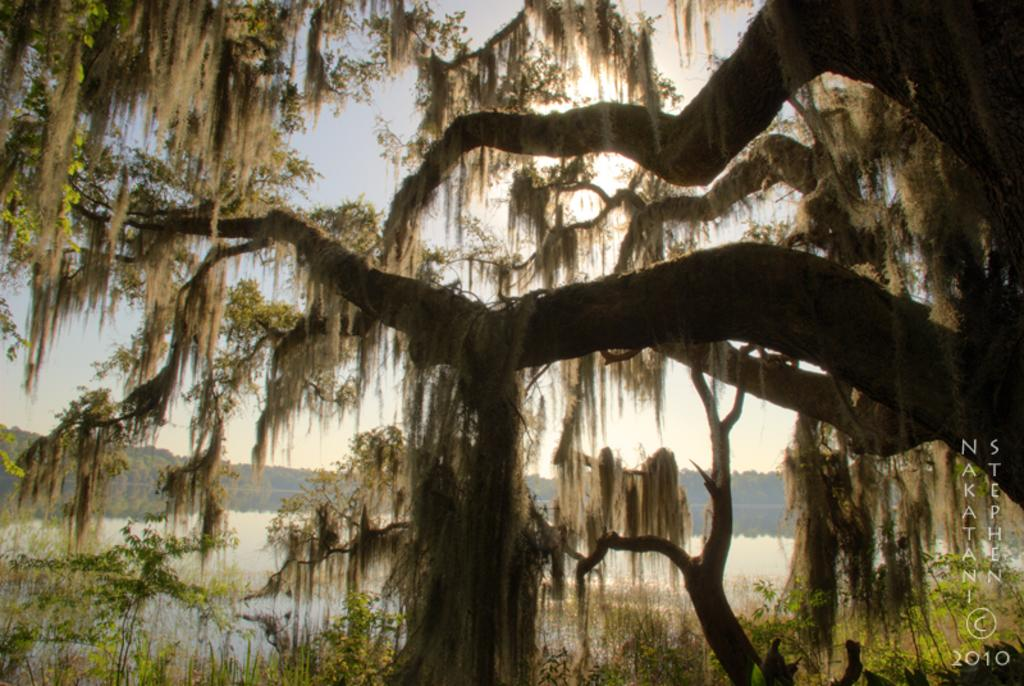What type of natural environment is depicted in the image? The image features trees and a lake, indicating a natural environment. What else can be seen in the sky in the image? The sky is visible in the image, but no specific details about the sky are mentioned in the facts. Is there any man-made structure or object in the image? No specific man-made structures or objects are mentioned in the facts. Where is the shop located in the image? There is no shop present in the image. What type of stick can be seen in the water of the lake? There is no stick visible in the water of the lake in the image. 